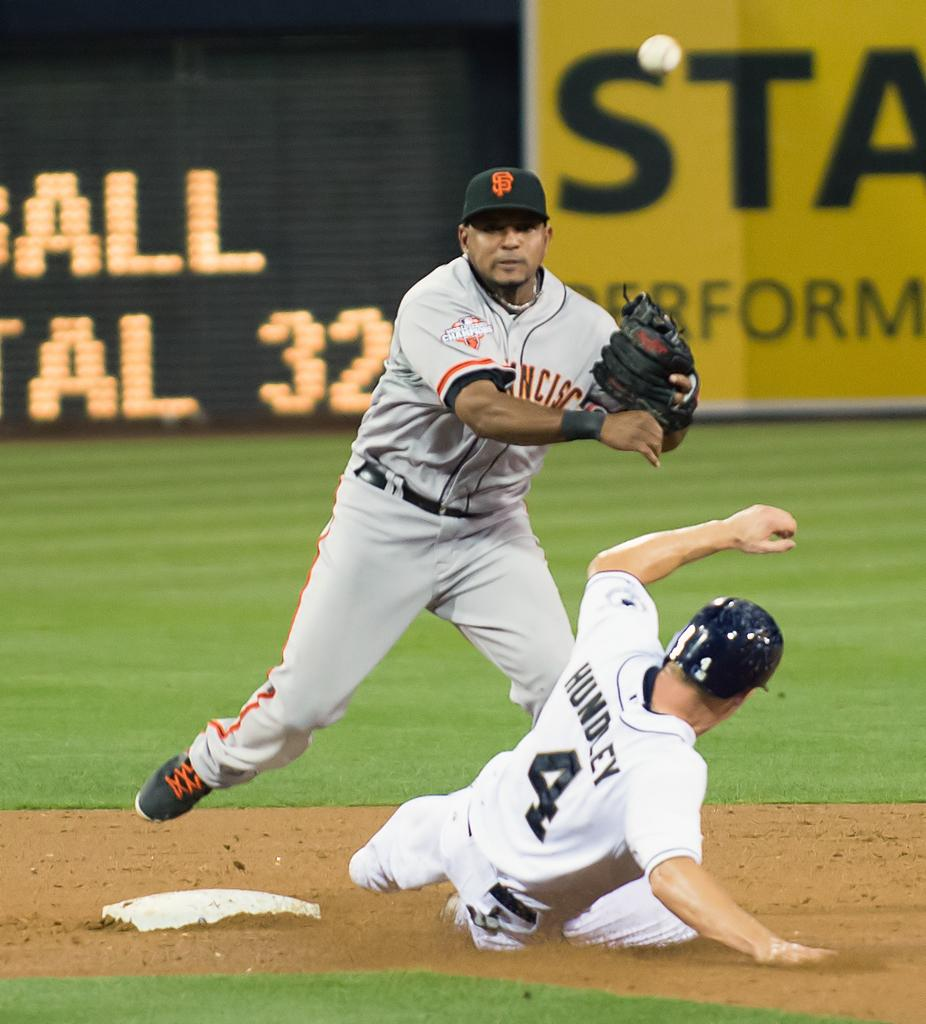<image>
Render a clear and concise summary of the photo. A baseball player named Hundley slides into base. 